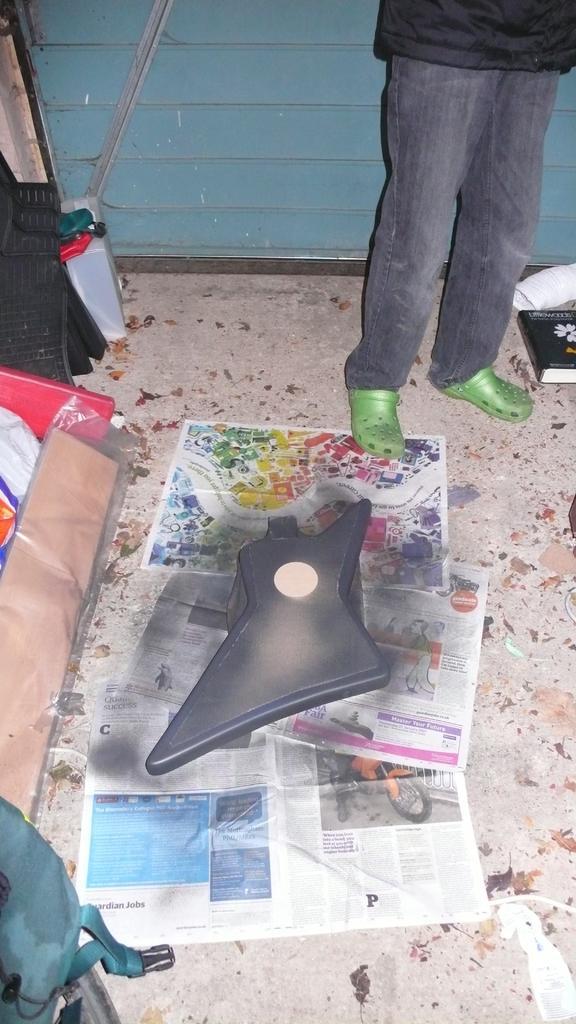Please provide a concise description of this image. In this image we can see a black color object is placed on the papers is kept on the floor. Here we can see bag, some objects, book and a person's legs wearing green color footwear. 